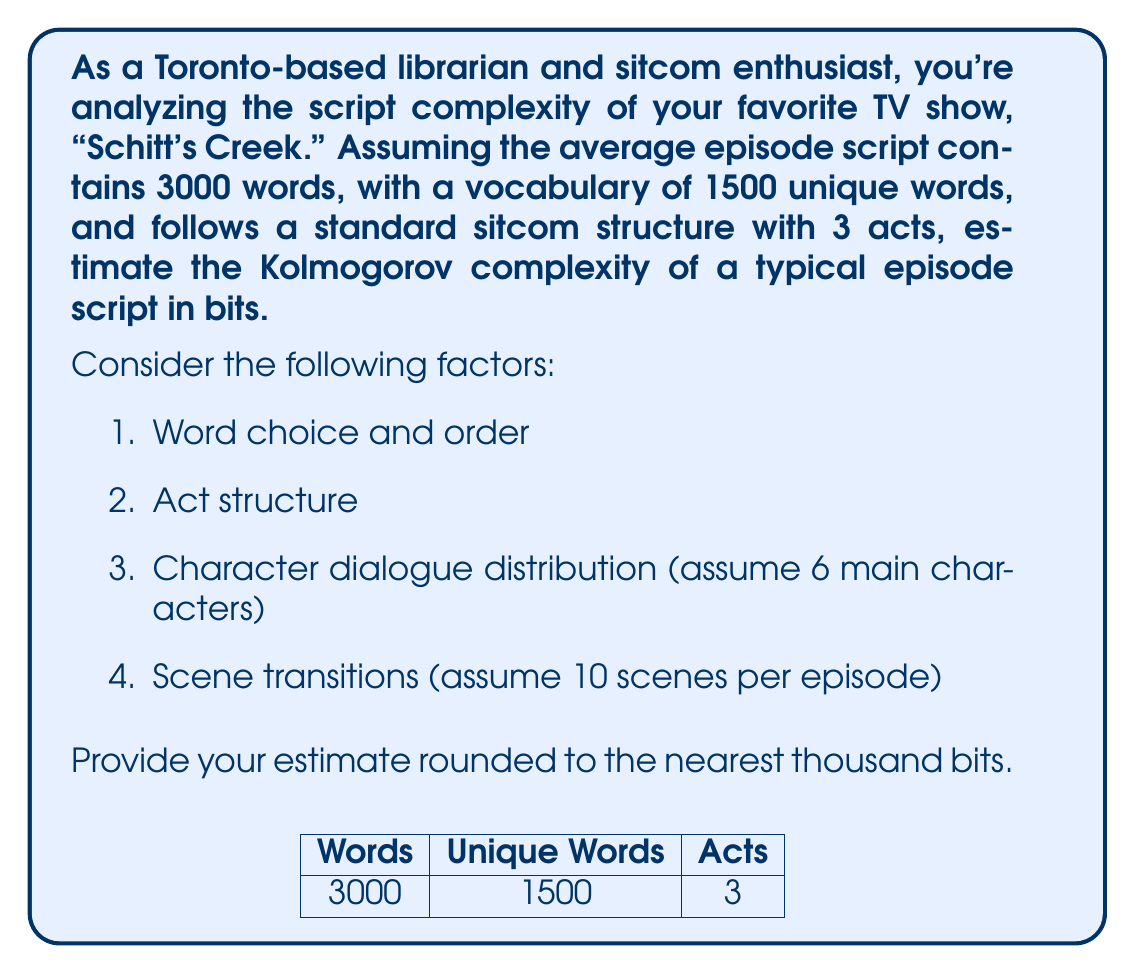Can you answer this question? Let's approach this step-by-step:

1. Word choice and order:
   The entropy of word choice can be estimated using Shannon's entropy formula:
   $$H = -\sum_{i=1}^{n} p(x_i) \log_2 p(x_i)$$
   Assuming a uniform distribution of words, we have:
   $$H = -1500 \cdot \frac{1}{1500} \log_2 \frac{1}{1500} \approx 10.55 \text{ bits/word}$$
   For 3000 words: $3000 \cdot 10.55 = 31,650 \text{ bits}$

2. Act structure:
   3 acts can be represented in $\log_2 3 \approx 1.58 \text{ bits}$

3. Character dialogue distribution:
   Assuming equal distribution among 6 characters, we need $\log_2 6 \approx 2.58 \text{ bits}$ per dialogue line.
   If we assume 200 dialogue lines per episode: $200 \cdot 2.58 = 516 \text{ bits}$

4. Scene transitions:
   10 scenes require $\log_2 10 \approx 3.32 \text{ bits}$ per transition.
   For 9 transitions: $9 \cdot 3.32 = 29.88 \text{ bits}$

5. Additional structure (e.g., stage directions, character names):
   Let's estimate this at about 1000 bits.

Total estimate:
$$31,650 + 1.58 + 516 + 29.88 + 1000 \approx 33,197 \text{ bits}$$

Rounding to the nearest thousand:
$$33,197 \approx 33,000 \text{ bits}$$

This estimate assumes a relatively simple encoding and doesn't account for more sophisticated compression techniques or the inherent structure of language, which could potentially reduce the complexity. However, it provides a reasonable upper bound for the Kolmogorov complexity of a typical "Schitt's Creek" episode script.
Answer: 33,000 bits 